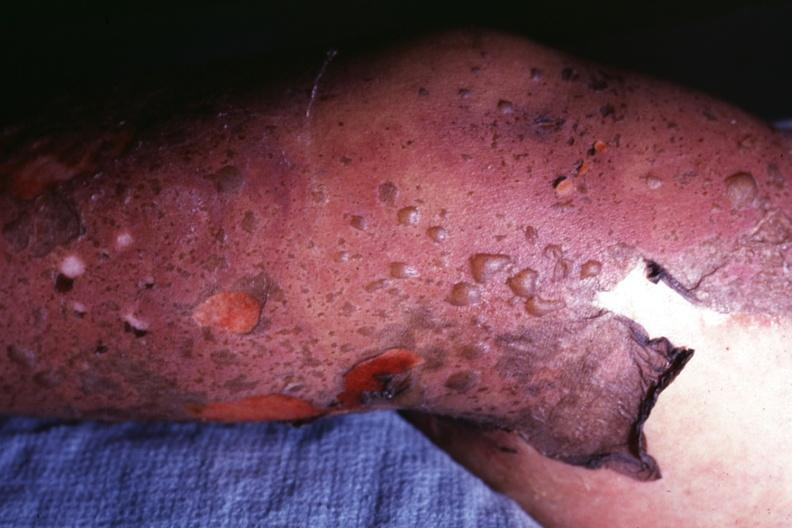s large cell lymphoma present?
Answer the question using a single word or phrase. No 